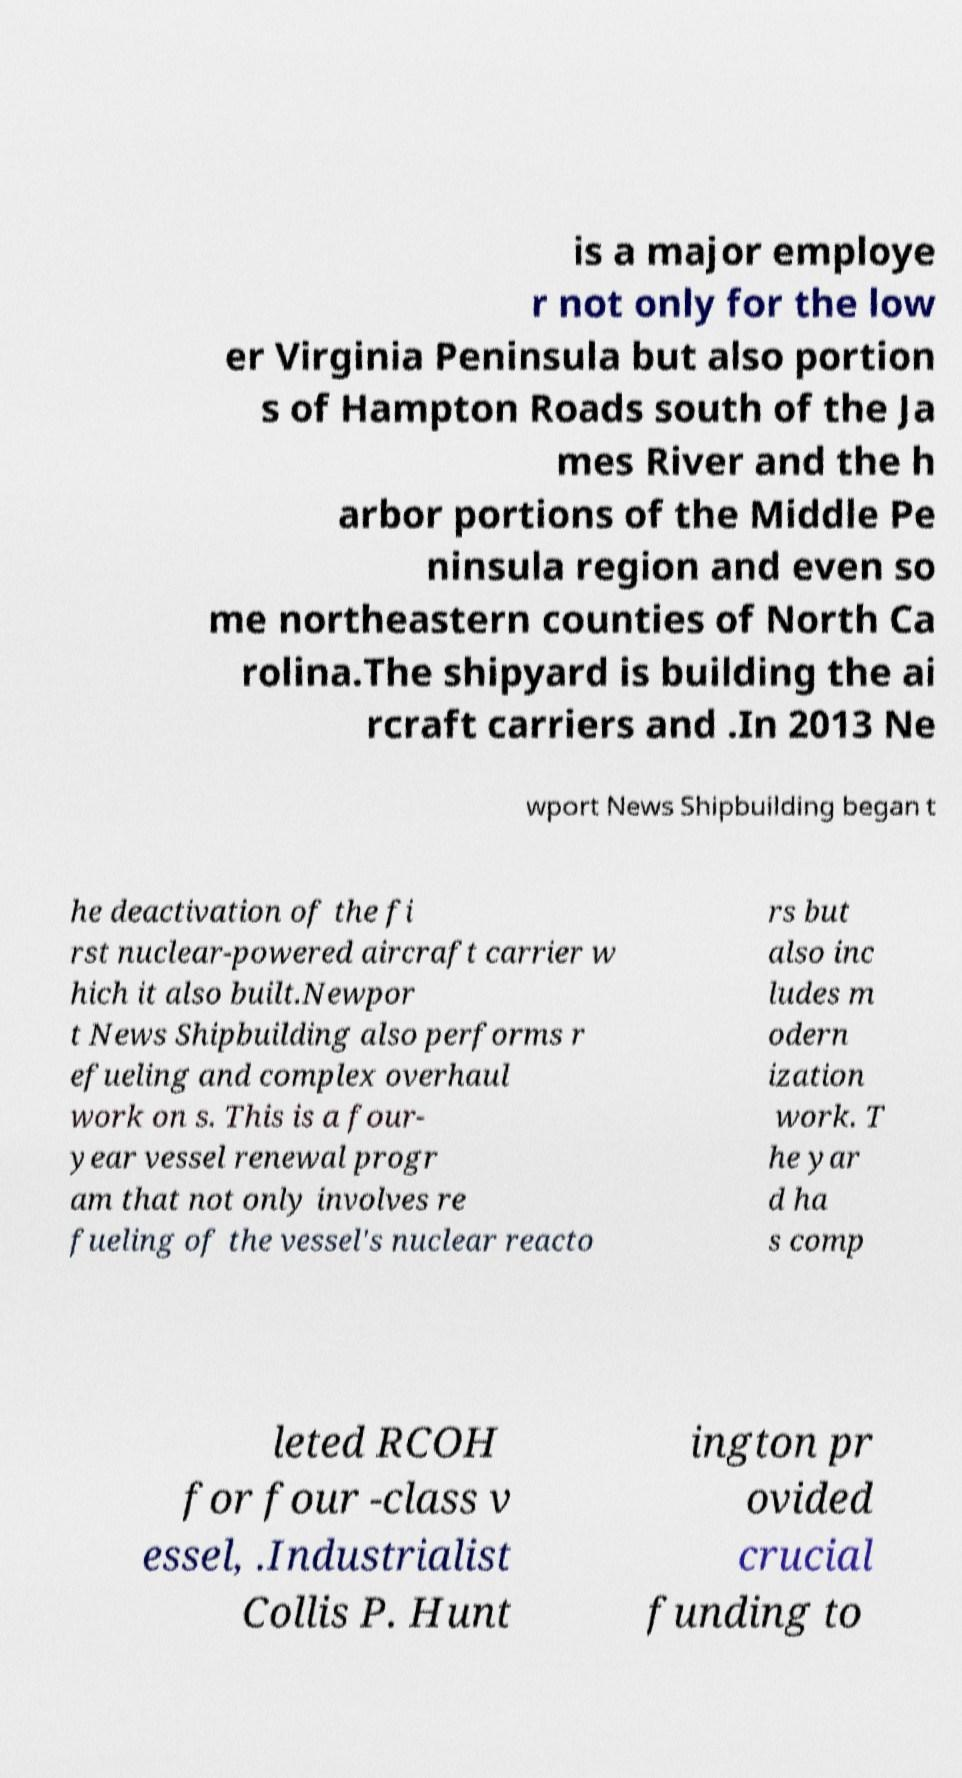Can you accurately transcribe the text from the provided image for me? is a major employe r not only for the low er Virginia Peninsula but also portion s of Hampton Roads south of the Ja mes River and the h arbor portions of the Middle Pe ninsula region and even so me northeastern counties of North Ca rolina.The shipyard is building the ai rcraft carriers and .In 2013 Ne wport News Shipbuilding began t he deactivation of the fi rst nuclear-powered aircraft carrier w hich it also built.Newpor t News Shipbuilding also performs r efueling and complex overhaul work on s. This is a four- year vessel renewal progr am that not only involves re fueling of the vessel's nuclear reacto rs but also inc ludes m odern ization work. T he yar d ha s comp leted RCOH for four -class v essel, .Industrialist Collis P. Hunt ington pr ovided crucial funding to 